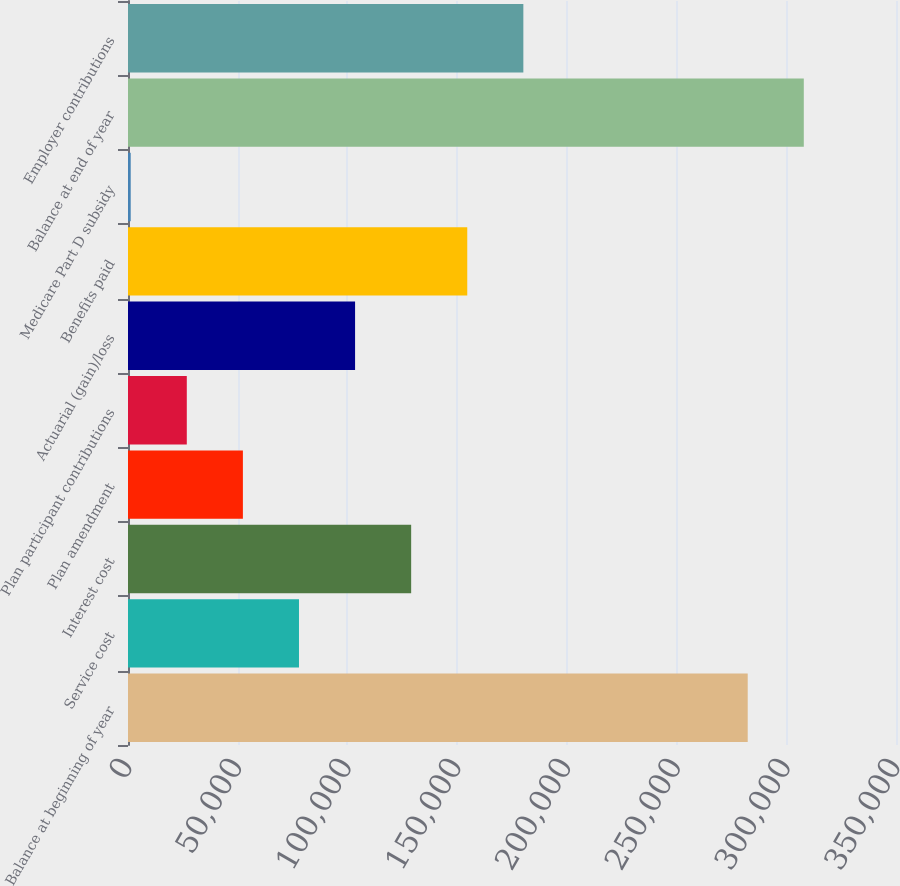Convert chart. <chart><loc_0><loc_0><loc_500><loc_500><bar_chart><fcel>Balance at beginning of year<fcel>Service cost<fcel>Interest cost<fcel>Plan amendment<fcel>Plan participant contributions<fcel>Actuarial (gain)/loss<fcel>Benefits paid<fcel>Medicare Part D subsidy<fcel>Balance at end of year<fcel>Employer contributions<nl><fcel>282421<fcel>77922.2<fcel>129047<fcel>52359.8<fcel>26797.4<fcel>103485<fcel>154609<fcel>1235<fcel>307984<fcel>180172<nl></chart> 